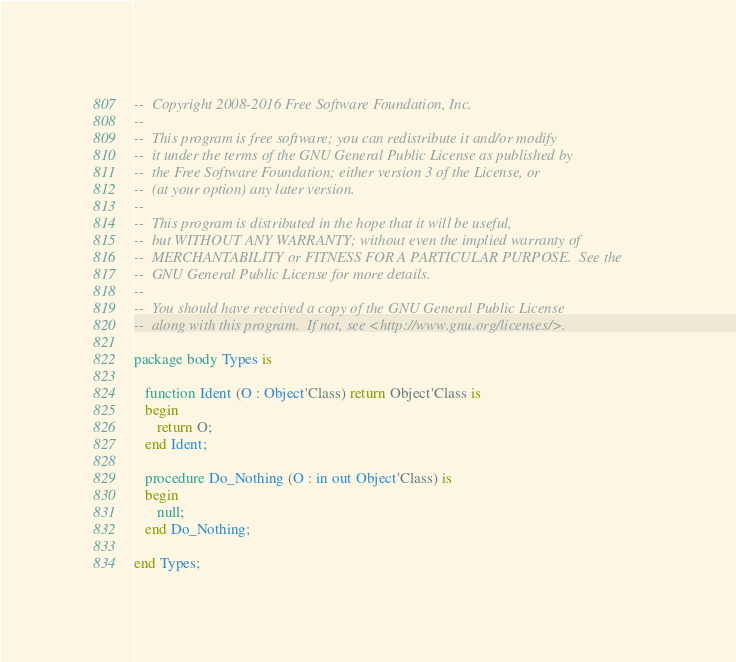Convert code to text. <code><loc_0><loc_0><loc_500><loc_500><_Ada_>--  Copyright 2008-2016 Free Software Foundation, Inc.
--
--  This program is free software; you can redistribute it and/or modify
--  it under the terms of the GNU General Public License as published by
--  the Free Software Foundation; either version 3 of the License, or
--  (at your option) any later version.
--
--  This program is distributed in the hope that it will be useful,
--  but WITHOUT ANY WARRANTY; without even the implied warranty of
--  MERCHANTABILITY or FITNESS FOR A PARTICULAR PURPOSE.  See the
--  GNU General Public License for more details.
--
--  You should have received a copy of the GNU General Public License
--  along with this program.  If not, see <http://www.gnu.org/licenses/>.

package body Types is

   function Ident (O : Object'Class) return Object'Class is
   begin
      return O;
   end Ident;

   procedure Do_Nothing (O : in out Object'Class) is
   begin
      null;
   end Do_Nothing;

end Types;

</code> 